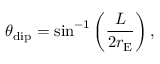Convert formula to latex. <formula><loc_0><loc_0><loc_500><loc_500>\theta _ { d i p } = \sin ^ { - 1 } \left ( \frac { L } { 2 r _ { E } } \right ) ,</formula> 